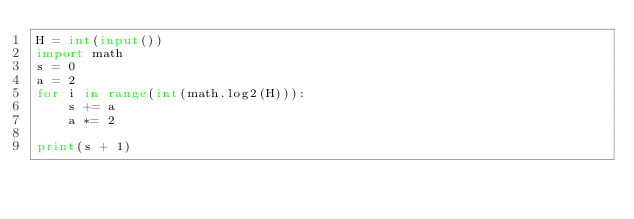Convert code to text. <code><loc_0><loc_0><loc_500><loc_500><_Python_>H = int(input())
import math
s = 0
a = 2
for i in range(int(math.log2(H))):
    s += a
    a *= 2

print(s + 1)
</code> 